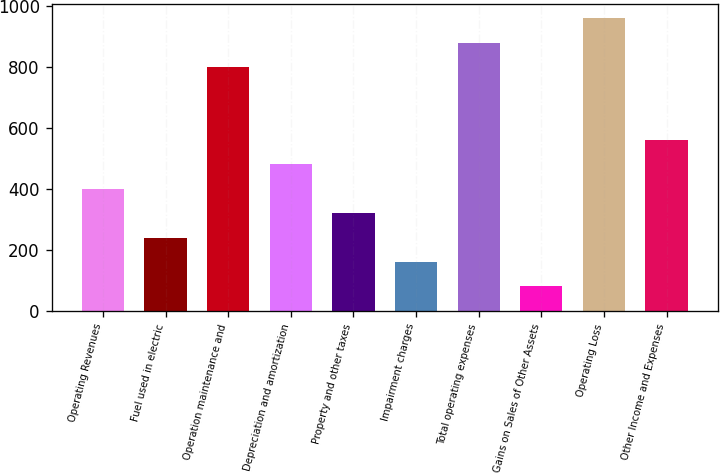<chart> <loc_0><loc_0><loc_500><loc_500><bar_chart><fcel>Operating Revenues<fcel>Fuel used in electric<fcel>Operation maintenance and<fcel>Depreciation and amortization<fcel>Property and other taxes<fcel>Impairment charges<fcel>Total operating expenses<fcel>Gains on Sales of Other Assets<fcel>Operating Loss<fcel>Other Income and Expenses<nl><fcel>400<fcel>240.4<fcel>799<fcel>479.8<fcel>320.2<fcel>160.6<fcel>878.8<fcel>80.8<fcel>958.6<fcel>559.6<nl></chart> 